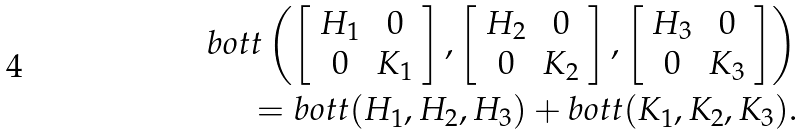<formula> <loc_0><loc_0><loc_500><loc_500>b o t t \left ( \left [ \begin{array} { c c } H _ { 1 } & 0 \\ 0 & K _ { 1 } \end{array} \right ] , \left [ \begin{array} { c c } H _ { 2 } & 0 \\ 0 & K _ { 2 } \end{array} \right ] , \left [ \begin{array} { c c } H _ { 3 } & 0 \\ 0 & K _ { 3 } \end{array} \right ] \right ) \\ = b o t t ( H _ { 1 } , H _ { 2 } , H _ { 3 } ) + b o t t ( K _ { 1 } , K _ { 2 } , K _ { 3 } ) .</formula> 